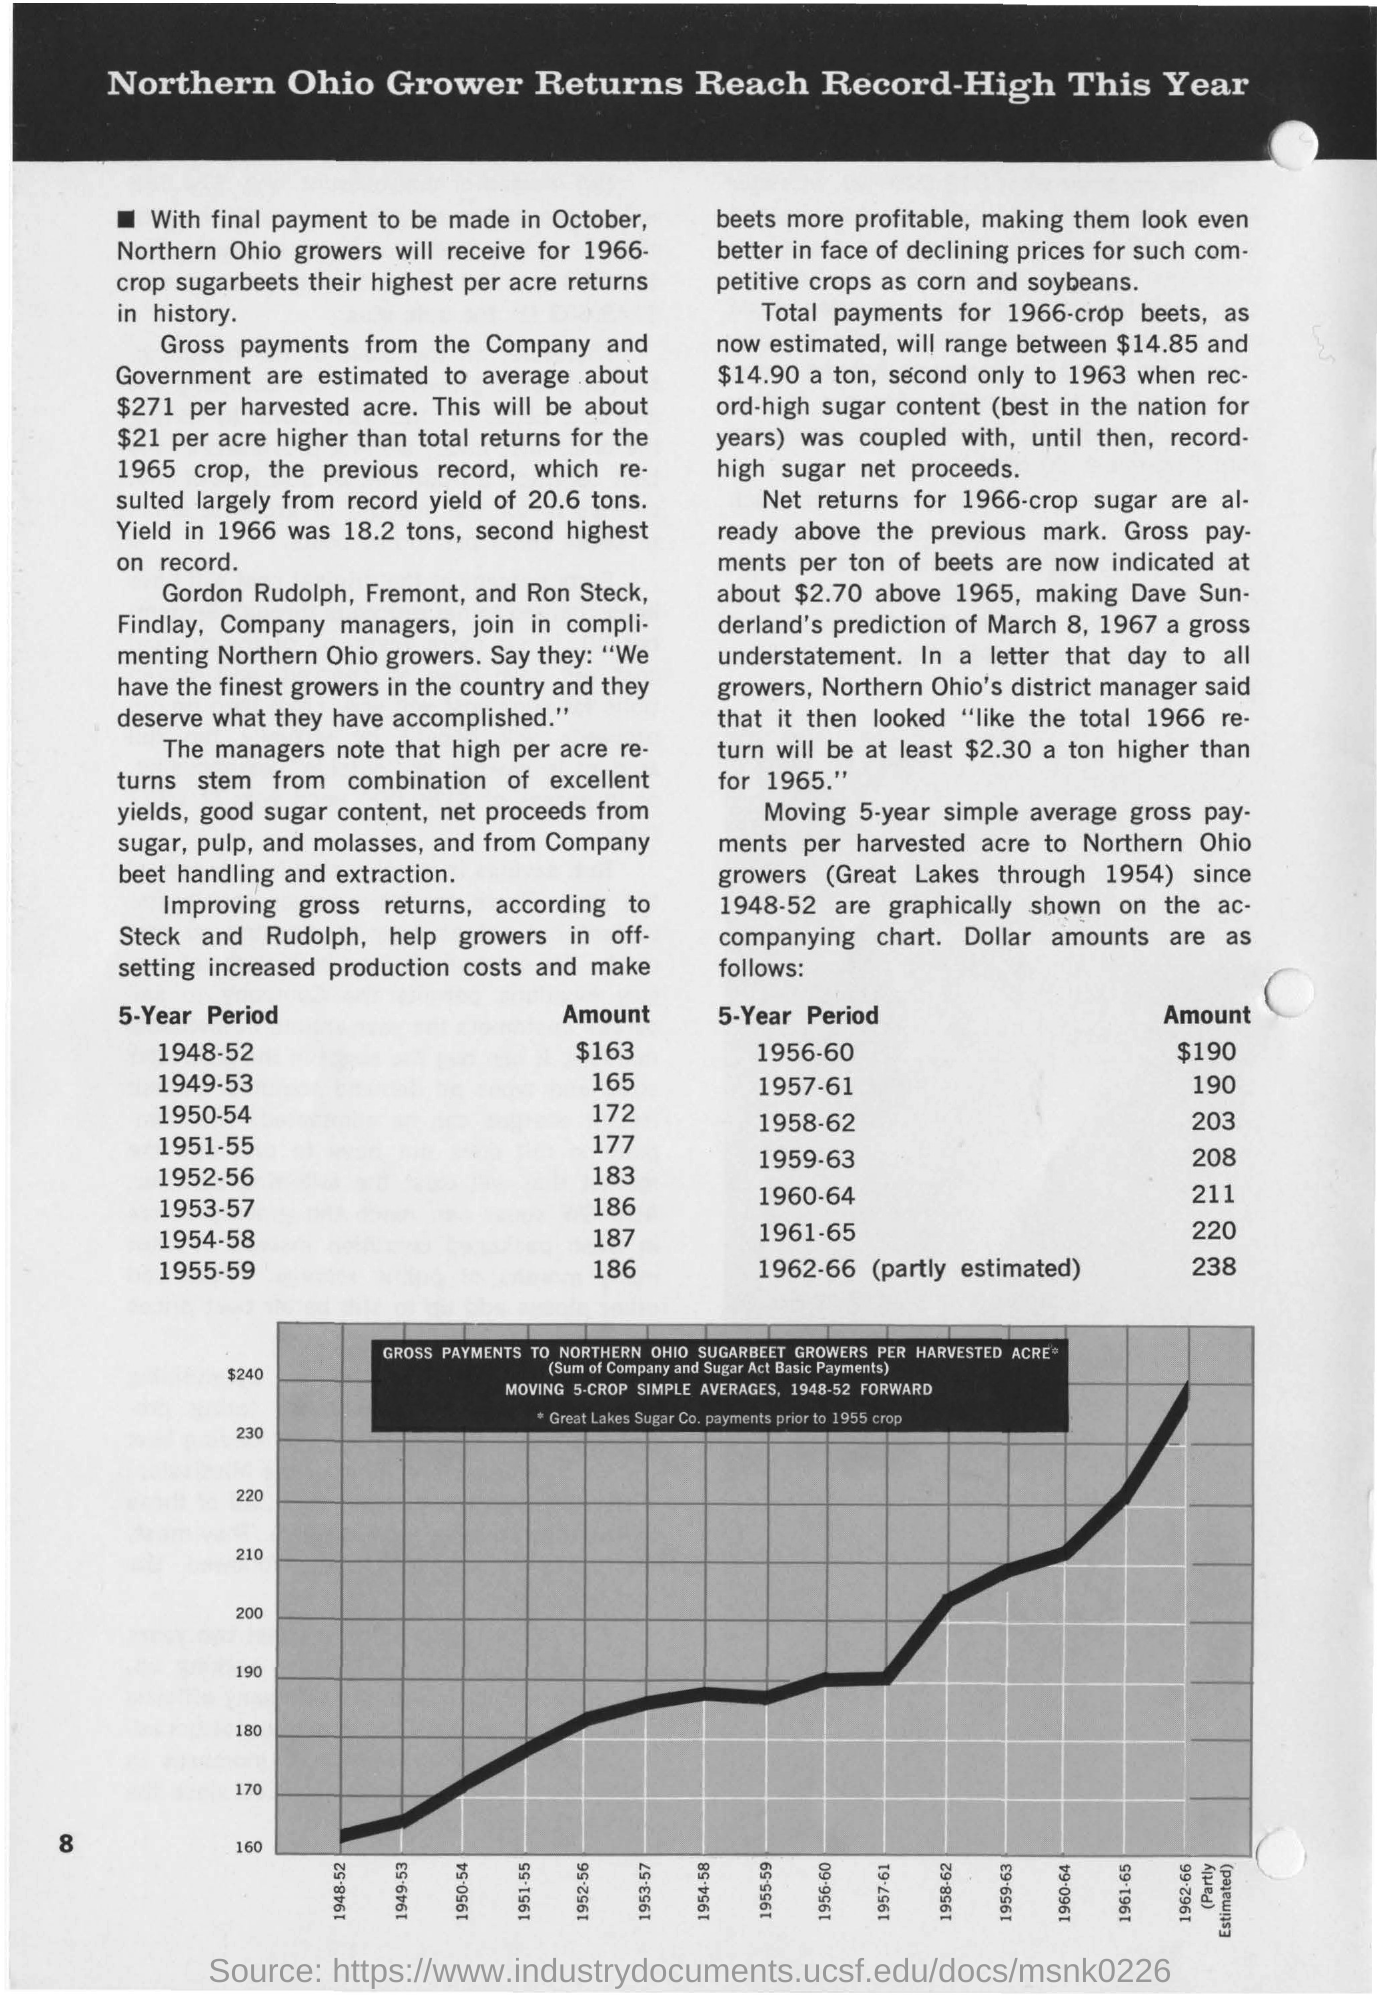What is the page number on this document?
Your answer should be compact. 8. What is the "amount" on the 5- year period 1948 - 52?
Keep it short and to the point. $163. What is the "amount" on the 5- year period 1956 - 60?
Provide a succinct answer. $190. What is the "amount" on the 5- year period 1949 - 53?
Offer a very short reply. 165. What is the "amount" on the 5- year period 1957 - 61?
Ensure brevity in your answer.  190. 